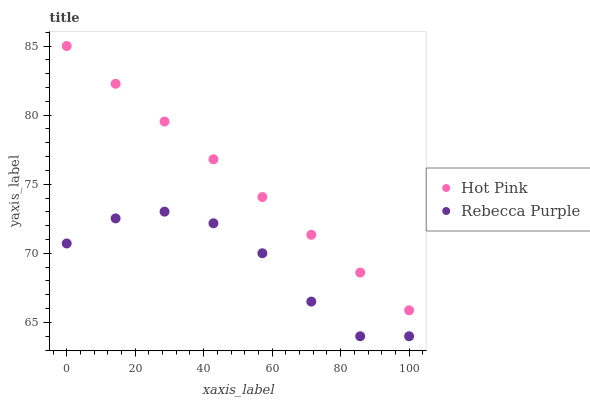Does Rebecca Purple have the minimum area under the curve?
Answer yes or no. Yes. Does Hot Pink have the maximum area under the curve?
Answer yes or no. Yes. Does Rebecca Purple have the maximum area under the curve?
Answer yes or no. No. Is Hot Pink the smoothest?
Answer yes or no. Yes. Is Rebecca Purple the roughest?
Answer yes or no. Yes. Is Rebecca Purple the smoothest?
Answer yes or no. No. Does Rebecca Purple have the lowest value?
Answer yes or no. Yes. Does Hot Pink have the highest value?
Answer yes or no. Yes. Does Rebecca Purple have the highest value?
Answer yes or no. No. Is Rebecca Purple less than Hot Pink?
Answer yes or no. Yes. Is Hot Pink greater than Rebecca Purple?
Answer yes or no. Yes. Does Rebecca Purple intersect Hot Pink?
Answer yes or no. No. 